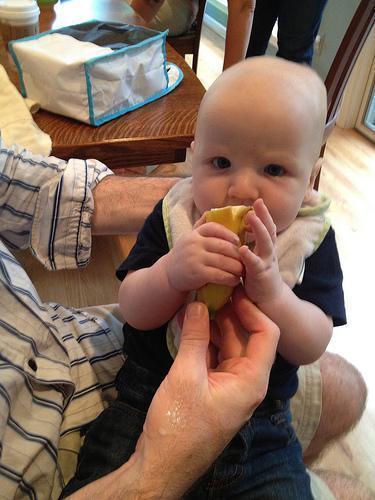How many babies are there?
Give a very brief answer. 1. 